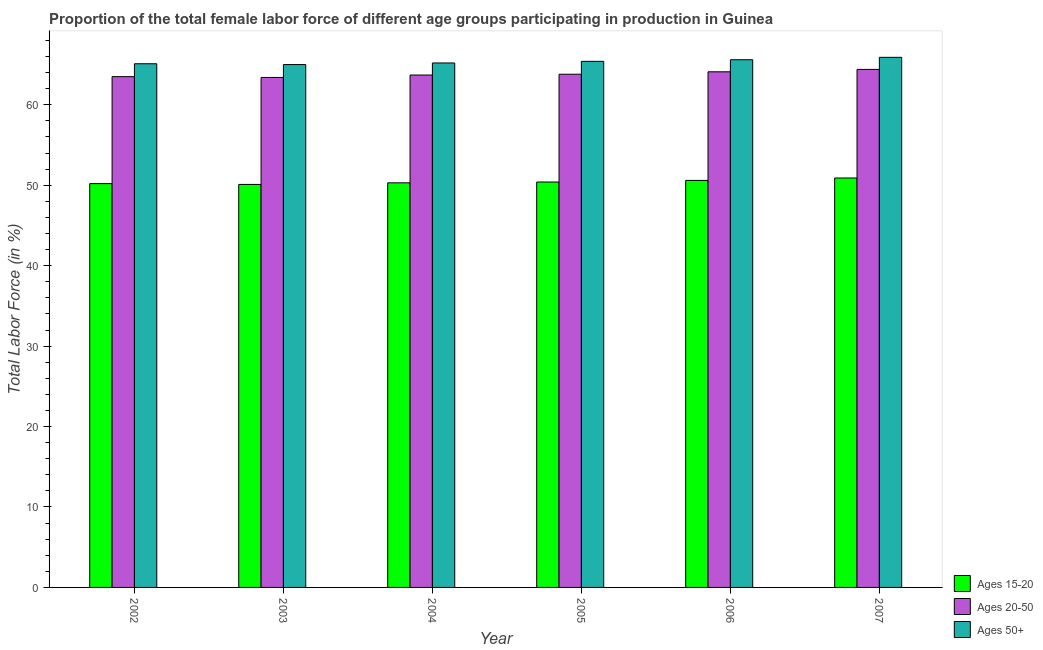How many groups of bars are there?
Keep it short and to the point. 6. Are the number of bars per tick equal to the number of legend labels?
Provide a succinct answer. Yes. Are the number of bars on each tick of the X-axis equal?
Provide a short and direct response. Yes. What is the label of the 2nd group of bars from the left?
Provide a short and direct response. 2003. What is the percentage of female labor force within the age group 15-20 in 2003?
Make the answer very short. 50.1. Across all years, what is the maximum percentage of female labor force within the age group 15-20?
Your response must be concise. 50.9. Across all years, what is the minimum percentage of female labor force above age 50?
Give a very brief answer. 65. In which year was the percentage of female labor force above age 50 minimum?
Offer a terse response. 2003. What is the total percentage of female labor force above age 50 in the graph?
Provide a succinct answer. 392.2. What is the difference between the percentage of female labor force above age 50 in 2003 and that in 2004?
Make the answer very short. -0.2. What is the difference between the percentage of female labor force within the age group 15-20 in 2002 and the percentage of female labor force within the age group 20-50 in 2005?
Keep it short and to the point. -0.2. What is the average percentage of female labor force within the age group 15-20 per year?
Offer a terse response. 50.42. What is the ratio of the percentage of female labor force within the age group 15-20 in 2004 to that in 2006?
Offer a very short reply. 0.99. Is the percentage of female labor force within the age group 15-20 in 2002 less than that in 2003?
Provide a succinct answer. No. Is the difference between the percentage of female labor force above age 50 in 2006 and 2007 greater than the difference between the percentage of female labor force within the age group 15-20 in 2006 and 2007?
Ensure brevity in your answer.  No. What is the difference between the highest and the second highest percentage of female labor force within the age group 20-50?
Offer a very short reply. 0.3. What is the difference between the highest and the lowest percentage of female labor force above age 50?
Keep it short and to the point. 0.9. In how many years, is the percentage of female labor force within the age group 15-20 greater than the average percentage of female labor force within the age group 15-20 taken over all years?
Your response must be concise. 2. Is the sum of the percentage of female labor force above age 50 in 2002 and 2007 greater than the maximum percentage of female labor force within the age group 15-20 across all years?
Keep it short and to the point. Yes. What does the 1st bar from the left in 2005 represents?
Offer a very short reply. Ages 15-20. What does the 2nd bar from the right in 2005 represents?
Your answer should be very brief. Ages 20-50. Is it the case that in every year, the sum of the percentage of female labor force within the age group 15-20 and percentage of female labor force within the age group 20-50 is greater than the percentage of female labor force above age 50?
Give a very brief answer. Yes. How many years are there in the graph?
Keep it short and to the point. 6. What is the difference between two consecutive major ticks on the Y-axis?
Offer a terse response. 10. Does the graph contain any zero values?
Provide a short and direct response. No. Does the graph contain grids?
Keep it short and to the point. No. Where does the legend appear in the graph?
Offer a terse response. Bottom right. How are the legend labels stacked?
Provide a short and direct response. Vertical. What is the title of the graph?
Ensure brevity in your answer.  Proportion of the total female labor force of different age groups participating in production in Guinea. What is the label or title of the Y-axis?
Make the answer very short. Total Labor Force (in %). What is the Total Labor Force (in %) of Ages 15-20 in 2002?
Your answer should be compact. 50.2. What is the Total Labor Force (in %) of Ages 20-50 in 2002?
Ensure brevity in your answer.  63.5. What is the Total Labor Force (in %) in Ages 50+ in 2002?
Your response must be concise. 65.1. What is the Total Labor Force (in %) of Ages 15-20 in 2003?
Provide a succinct answer. 50.1. What is the Total Labor Force (in %) in Ages 20-50 in 2003?
Provide a short and direct response. 63.4. What is the Total Labor Force (in %) in Ages 50+ in 2003?
Your response must be concise. 65. What is the Total Labor Force (in %) of Ages 15-20 in 2004?
Offer a terse response. 50.3. What is the Total Labor Force (in %) in Ages 20-50 in 2004?
Your response must be concise. 63.7. What is the Total Labor Force (in %) of Ages 50+ in 2004?
Keep it short and to the point. 65.2. What is the Total Labor Force (in %) in Ages 15-20 in 2005?
Offer a terse response. 50.4. What is the Total Labor Force (in %) of Ages 20-50 in 2005?
Give a very brief answer. 63.8. What is the Total Labor Force (in %) in Ages 50+ in 2005?
Offer a terse response. 65.4. What is the Total Labor Force (in %) in Ages 15-20 in 2006?
Your answer should be very brief. 50.6. What is the Total Labor Force (in %) of Ages 20-50 in 2006?
Your answer should be compact. 64.1. What is the Total Labor Force (in %) in Ages 50+ in 2006?
Your answer should be very brief. 65.6. What is the Total Labor Force (in %) of Ages 15-20 in 2007?
Provide a succinct answer. 50.9. What is the Total Labor Force (in %) in Ages 20-50 in 2007?
Your answer should be very brief. 64.4. What is the Total Labor Force (in %) in Ages 50+ in 2007?
Provide a short and direct response. 65.9. Across all years, what is the maximum Total Labor Force (in %) in Ages 15-20?
Your answer should be compact. 50.9. Across all years, what is the maximum Total Labor Force (in %) in Ages 20-50?
Your answer should be very brief. 64.4. Across all years, what is the maximum Total Labor Force (in %) in Ages 50+?
Your response must be concise. 65.9. Across all years, what is the minimum Total Labor Force (in %) of Ages 15-20?
Make the answer very short. 50.1. Across all years, what is the minimum Total Labor Force (in %) of Ages 20-50?
Make the answer very short. 63.4. What is the total Total Labor Force (in %) of Ages 15-20 in the graph?
Your answer should be compact. 302.5. What is the total Total Labor Force (in %) of Ages 20-50 in the graph?
Offer a very short reply. 382.9. What is the total Total Labor Force (in %) in Ages 50+ in the graph?
Your answer should be very brief. 392.2. What is the difference between the Total Labor Force (in %) in Ages 50+ in 2002 and that in 2003?
Offer a terse response. 0.1. What is the difference between the Total Labor Force (in %) of Ages 15-20 in 2002 and that in 2004?
Keep it short and to the point. -0.1. What is the difference between the Total Labor Force (in %) of Ages 20-50 in 2002 and that in 2004?
Offer a terse response. -0.2. What is the difference between the Total Labor Force (in %) in Ages 15-20 in 2002 and that in 2005?
Give a very brief answer. -0.2. What is the difference between the Total Labor Force (in %) of Ages 20-50 in 2002 and that in 2005?
Ensure brevity in your answer.  -0.3. What is the difference between the Total Labor Force (in %) in Ages 50+ in 2002 and that in 2005?
Offer a terse response. -0.3. What is the difference between the Total Labor Force (in %) of Ages 20-50 in 2002 and that in 2006?
Make the answer very short. -0.6. What is the difference between the Total Labor Force (in %) in Ages 50+ in 2003 and that in 2004?
Offer a very short reply. -0.2. What is the difference between the Total Labor Force (in %) in Ages 15-20 in 2003 and that in 2006?
Ensure brevity in your answer.  -0.5. What is the difference between the Total Labor Force (in %) in Ages 20-50 in 2003 and that in 2006?
Your answer should be compact. -0.7. What is the difference between the Total Labor Force (in %) of Ages 50+ in 2003 and that in 2006?
Offer a very short reply. -0.6. What is the difference between the Total Labor Force (in %) in Ages 15-20 in 2003 and that in 2007?
Ensure brevity in your answer.  -0.8. What is the difference between the Total Labor Force (in %) in Ages 20-50 in 2003 and that in 2007?
Your answer should be compact. -1. What is the difference between the Total Labor Force (in %) in Ages 50+ in 2003 and that in 2007?
Ensure brevity in your answer.  -0.9. What is the difference between the Total Labor Force (in %) of Ages 15-20 in 2004 and that in 2006?
Ensure brevity in your answer.  -0.3. What is the difference between the Total Labor Force (in %) in Ages 20-50 in 2004 and that in 2006?
Offer a terse response. -0.4. What is the difference between the Total Labor Force (in %) in Ages 50+ in 2004 and that in 2006?
Provide a succinct answer. -0.4. What is the difference between the Total Labor Force (in %) of Ages 20-50 in 2004 and that in 2007?
Offer a very short reply. -0.7. What is the difference between the Total Labor Force (in %) of Ages 15-20 in 2005 and that in 2006?
Provide a short and direct response. -0.2. What is the difference between the Total Labor Force (in %) in Ages 20-50 in 2005 and that in 2006?
Your answer should be very brief. -0.3. What is the difference between the Total Labor Force (in %) of Ages 15-20 in 2005 and that in 2007?
Provide a short and direct response. -0.5. What is the difference between the Total Labor Force (in %) in Ages 20-50 in 2005 and that in 2007?
Your response must be concise. -0.6. What is the difference between the Total Labor Force (in %) in Ages 15-20 in 2006 and that in 2007?
Ensure brevity in your answer.  -0.3. What is the difference between the Total Labor Force (in %) in Ages 50+ in 2006 and that in 2007?
Offer a terse response. -0.3. What is the difference between the Total Labor Force (in %) of Ages 15-20 in 2002 and the Total Labor Force (in %) of Ages 50+ in 2003?
Ensure brevity in your answer.  -14.8. What is the difference between the Total Labor Force (in %) of Ages 20-50 in 2002 and the Total Labor Force (in %) of Ages 50+ in 2003?
Offer a terse response. -1.5. What is the difference between the Total Labor Force (in %) of Ages 15-20 in 2002 and the Total Labor Force (in %) of Ages 50+ in 2004?
Your answer should be very brief. -15. What is the difference between the Total Labor Force (in %) in Ages 15-20 in 2002 and the Total Labor Force (in %) in Ages 50+ in 2005?
Offer a terse response. -15.2. What is the difference between the Total Labor Force (in %) in Ages 20-50 in 2002 and the Total Labor Force (in %) in Ages 50+ in 2005?
Your response must be concise. -1.9. What is the difference between the Total Labor Force (in %) in Ages 15-20 in 2002 and the Total Labor Force (in %) in Ages 50+ in 2006?
Provide a short and direct response. -15.4. What is the difference between the Total Labor Force (in %) in Ages 20-50 in 2002 and the Total Labor Force (in %) in Ages 50+ in 2006?
Keep it short and to the point. -2.1. What is the difference between the Total Labor Force (in %) of Ages 15-20 in 2002 and the Total Labor Force (in %) of Ages 50+ in 2007?
Provide a succinct answer. -15.7. What is the difference between the Total Labor Force (in %) in Ages 20-50 in 2002 and the Total Labor Force (in %) in Ages 50+ in 2007?
Offer a very short reply. -2.4. What is the difference between the Total Labor Force (in %) in Ages 15-20 in 2003 and the Total Labor Force (in %) in Ages 20-50 in 2004?
Provide a succinct answer. -13.6. What is the difference between the Total Labor Force (in %) in Ages 15-20 in 2003 and the Total Labor Force (in %) in Ages 50+ in 2004?
Make the answer very short. -15.1. What is the difference between the Total Labor Force (in %) of Ages 15-20 in 2003 and the Total Labor Force (in %) of Ages 20-50 in 2005?
Your answer should be compact. -13.7. What is the difference between the Total Labor Force (in %) of Ages 15-20 in 2003 and the Total Labor Force (in %) of Ages 50+ in 2005?
Provide a short and direct response. -15.3. What is the difference between the Total Labor Force (in %) of Ages 20-50 in 2003 and the Total Labor Force (in %) of Ages 50+ in 2005?
Ensure brevity in your answer.  -2. What is the difference between the Total Labor Force (in %) of Ages 15-20 in 2003 and the Total Labor Force (in %) of Ages 20-50 in 2006?
Offer a terse response. -14. What is the difference between the Total Labor Force (in %) of Ages 15-20 in 2003 and the Total Labor Force (in %) of Ages 50+ in 2006?
Provide a short and direct response. -15.5. What is the difference between the Total Labor Force (in %) in Ages 15-20 in 2003 and the Total Labor Force (in %) in Ages 20-50 in 2007?
Offer a terse response. -14.3. What is the difference between the Total Labor Force (in %) of Ages 15-20 in 2003 and the Total Labor Force (in %) of Ages 50+ in 2007?
Provide a short and direct response. -15.8. What is the difference between the Total Labor Force (in %) in Ages 20-50 in 2003 and the Total Labor Force (in %) in Ages 50+ in 2007?
Ensure brevity in your answer.  -2.5. What is the difference between the Total Labor Force (in %) in Ages 15-20 in 2004 and the Total Labor Force (in %) in Ages 50+ in 2005?
Your response must be concise. -15.1. What is the difference between the Total Labor Force (in %) in Ages 15-20 in 2004 and the Total Labor Force (in %) in Ages 50+ in 2006?
Make the answer very short. -15.3. What is the difference between the Total Labor Force (in %) in Ages 20-50 in 2004 and the Total Labor Force (in %) in Ages 50+ in 2006?
Ensure brevity in your answer.  -1.9. What is the difference between the Total Labor Force (in %) of Ages 15-20 in 2004 and the Total Labor Force (in %) of Ages 20-50 in 2007?
Give a very brief answer. -14.1. What is the difference between the Total Labor Force (in %) of Ages 15-20 in 2004 and the Total Labor Force (in %) of Ages 50+ in 2007?
Your answer should be very brief. -15.6. What is the difference between the Total Labor Force (in %) in Ages 15-20 in 2005 and the Total Labor Force (in %) in Ages 20-50 in 2006?
Ensure brevity in your answer.  -13.7. What is the difference between the Total Labor Force (in %) of Ages 15-20 in 2005 and the Total Labor Force (in %) of Ages 50+ in 2006?
Offer a terse response. -15.2. What is the difference between the Total Labor Force (in %) of Ages 20-50 in 2005 and the Total Labor Force (in %) of Ages 50+ in 2006?
Your answer should be compact. -1.8. What is the difference between the Total Labor Force (in %) of Ages 15-20 in 2005 and the Total Labor Force (in %) of Ages 20-50 in 2007?
Provide a succinct answer. -14. What is the difference between the Total Labor Force (in %) in Ages 15-20 in 2005 and the Total Labor Force (in %) in Ages 50+ in 2007?
Offer a terse response. -15.5. What is the difference between the Total Labor Force (in %) in Ages 15-20 in 2006 and the Total Labor Force (in %) in Ages 50+ in 2007?
Give a very brief answer. -15.3. What is the difference between the Total Labor Force (in %) in Ages 20-50 in 2006 and the Total Labor Force (in %) in Ages 50+ in 2007?
Ensure brevity in your answer.  -1.8. What is the average Total Labor Force (in %) in Ages 15-20 per year?
Make the answer very short. 50.42. What is the average Total Labor Force (in %) in Ages 20-50 per year?
Provide a short and direct response. 63.82. What is the average Total Labor Force (in %) of Ages 50+ per year?
Provide a short and direct response. 65.37. In the year 2002, what is the difference between the Total Labor Force (in %) in Ages 15-20 and Total Labor Force (in %) in Ages 20-50?
Your answer should be very brief. -13.3. In the year 2002, what is the difference between the Total Labor Force (in %) of Ages 15-20 and Total Labor Force (in %) of Ages 50+?
Your answer should be compact. -14.9. In the year 2003, what is the difference between the Total Labor Force (in %) in Ages 15-20 and Total Labor Force (in %) in Ages 50+?
Your answer should be very brief. -14.9. In the year 2004, what is the difference between the Total Labor Force (in %) in Ages 15-20 and Total Labor Force (in %) in Ages 20-50?
Your answer should be very brief. -13.4. In the year 2004, what is the difference between the Total Labor Force (in %) in Ages 15-20 and Total Labor Force (in %) in Ages 50+?
Make the answer very short. -14.9. In the year 2004, what is the difference between the Total Labor Force (in %) in Ages 20-50 and Total Labor Force (in %) in Ages 50+?
Offer a terse response. -1.5. In the year 2005, what is the difference between the Total Labor Force (in %) in Ages 15-20 and Total Labor Force (in %) in Ages 50+?
Offer a very short reply. -15. In the year 2006, what is the difference between the Total Labor Force (in %) in Ages 15-20 and Total Labor Force (in %) in Ages 50+?
Provide a short and direct response. -15. In the year 2006, what is the difference between the Total Labor Force (in %) in Ages 20-50 and Total Labor Force (in %) in Ages 50+?
Offer a very short reply. -1.5. In the year 2007, what is the difference between the Total Labor Force (in %) in Ages 15-20 and Total Labor Force (in %) in Ages 50+?
Ensure brevity in your answer.  -15. What is the ratio of the Total Labor Force (in %) in Ages 50+ in 2002 to that in 2003?
Your answer should be compact. 1. What is the ratio of the Total Labor Force (in %) of Ages 15-20 in 2002 to that in 2004?
Offer a terse response. 1. What is the ratio of the Total Labor Force (in %) of Ages 20-50 in 2002 to that in 2006?
Make the answer very short. 0.99. What is the ratio of the Total Labor Force (in %) of Ages 50+ in 2002 to that in 2006?
Keep it short and to the point. 0.99. What is the ratio of the Total Labor Force (in %) of Ages 15-20 in 2002 to that in 2007?
Provide a short and direct response. 0.99. What is the ratio of the Total Labor Force (in %) in Ages 50+ in 2002 to that in 2007?
Make the answer very short. 0.99. What is the ratio of the Total Labor Force (in %) in Ages 15-20 in 2003 to that in 2004?
Offer a terse response. 1. What is the ratio of the Total Labor Force (in %) of Ages 50+ in 2003 to that in 2004?
Offer a terse response. 1. What is the ratio of the Total Labor Force (in %) in Ages 15-20 in 2003 to that in 2005?
Make the answer very short. 0.99. What is the ratio of the Total Labor Force (in %) in Ages 50+ in 2003 to that in 2006?
Offer a terse response. 0.99. What is the ratio of the Total Labor Force (in %) in Ages 15-20 in 2003 to that in 2007?
Your answer should be compact. 0.98. What is the ratio of the Total Labor Force (in %) in Ages 20-50 in 2003 to that in 2007?
Your response must be concise. 0.98. What is the ratio of the Total Labor Force (in %) in Ages 50+ in 2003 to that in 2007?
Make the answer very short. 0.99. What is the ratio of the Total Labor Force (in %) of Ages 20-50 in 2004 to that in 2005?
Offer a terse response. 1. What is the ratio of the Total Labor Force (in %) of Ages 15-20 in 2004 to that in 2006?
Keep it short and to the point. 0.99. What is the ratio of the Total Labor Force (in %) of Ages 50+ in 2004 to that in 2006?
Your answer should be compact. 0.99. What is the ratio of the Total Labor Force (in %) of Ages 15-20 in 2004 to that in 2007?
Provide a succinct answer. 0.99. What is the ratio of the Total Labor Force (in %) in Ages 20-50 in 2004 to that in 2007?
Ensure brevity in your answer.  0.99. What is the ratio of the Total Labor Force (in %) of Ages 15-20 in 2005 to that in 2006?
Give a very brief answer. 1. What is the ratio of the Total Labor Force (in %) of Ages 50+ in 2005 to that in 2006?
Give a very brief answer. 1. What is the ratio of the Total Labor Force (in %) in Ages 15-20 in 2005 to that in 2007?
Give a very brief answer. 0.99. What is the ratio of the Total Labor Force (in %) of Ages 15-20 in 2006 to that in 2007?
Your answer should be compact. 0.99. What is the ratio of the Total Labor Force (in %) of Ages 50+ in 2006 to that in 2007?
Keep it short and to the point. 1. What is the difference between the highest and the second highest Total Labor Force (in %) of Ages 15-20?
Ensure brevity in your answer.  0.3. What is the difference between the highest and the second highest Total Labor Force (in %) of Ages 50+?
Ensure brevity in your answer.  0.3. What is the difference between the highest and the lowest Total Labor Force (in %) of Ages 15-20?
Your response must be concise. 0.8. What is the difference between the highest and the lowest Total Labor Force (in %) in Ages 20-50?
Keep it short and to the point. 1. 